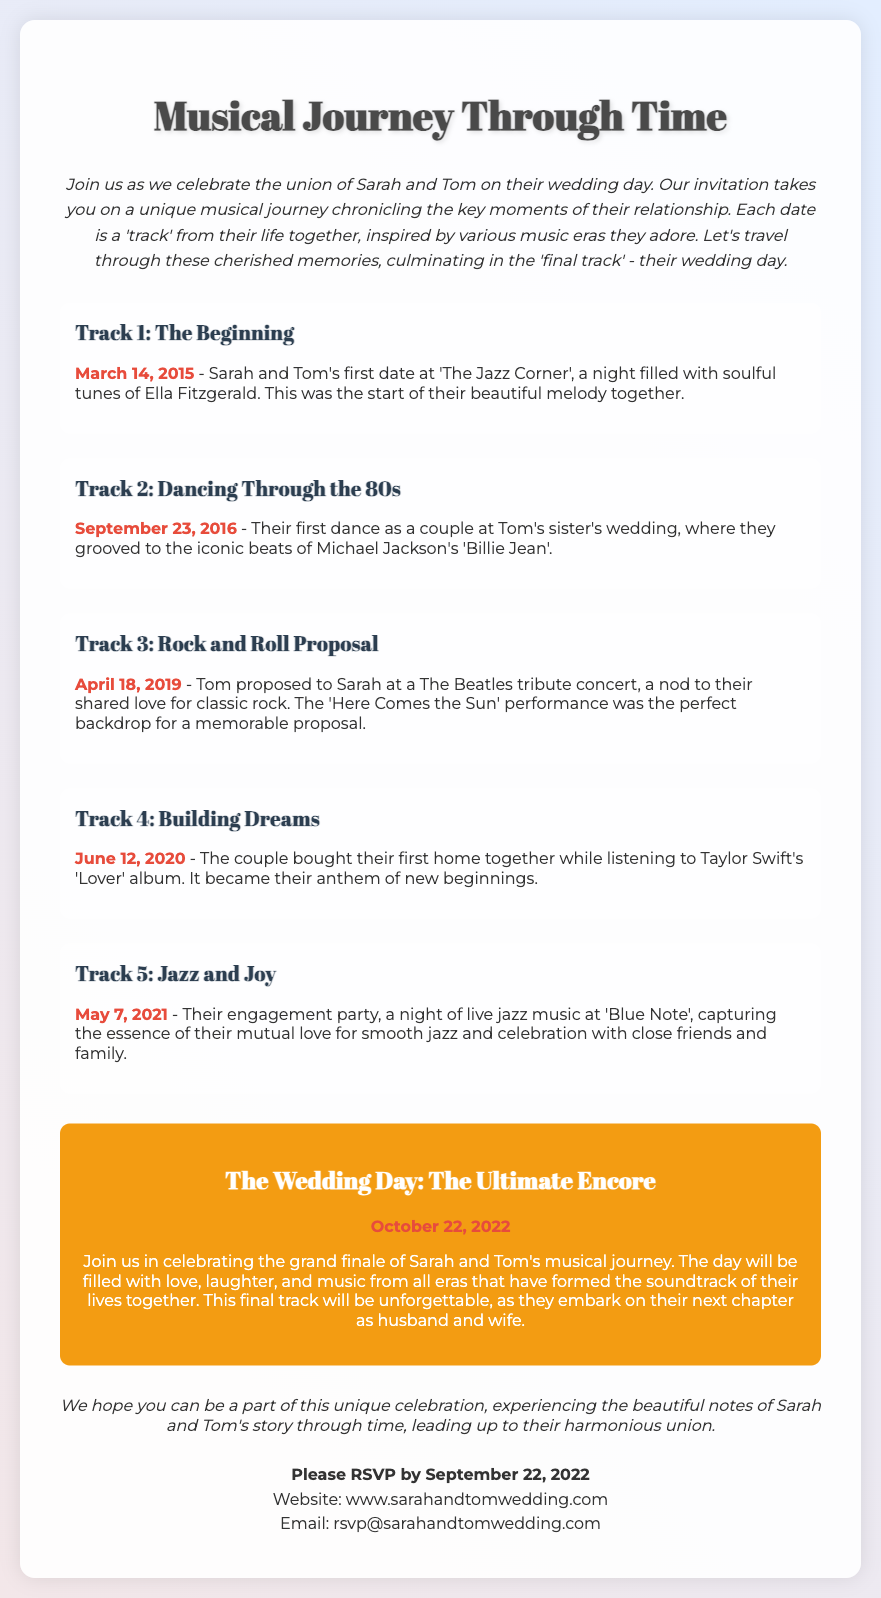what is the title of the wedding invitation? The title of the wedding invitation is prominently displayed at the top of the document, which is "Musical Journey Through Time."
Answer: Musical Journey Through Time what date is the wedding day? The wedding day is indicated as the final track in the invitation, highlighted with the date provided.
Answer: October 22, 2022 who are the couple getting married? The invitation introduces the couple by mentioning their names at the beginning of the document.
Answer: Sarah and Tom what was the first track date? The first track is presented with its specific date, marking an important moment in the couple's relationship.
Answer: March 14, 2015 which song was played during their engagement party? The engagement party track mentions a specific event and song that characterized the night.
Answer: live jazz music why was their first date significant? The description of their first date explains the context and importance it holds in their relationship timeline.
Answer: it was the start of their beautiful melody together what genre of music is mentioned in the engagement party? The engagement party reflects the couple's musical preferences, which are highlighted in the description.
Answer: jazz what was the iconic song during their first dance? A specific song is cited in relation to the couple's early experiences together during a significant event.
Answer: Billie Jean when did they buy their first home? The date when they achieved this milestone is specified in the timeline of their relationship.
Answer: June 12, 2020 